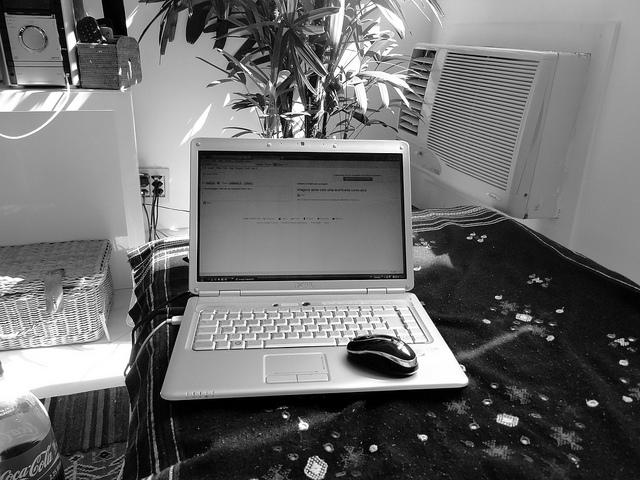Why would someone sit at this area? Please explain your reasoning. work. Most people in this scenario will use the laptop for work. 